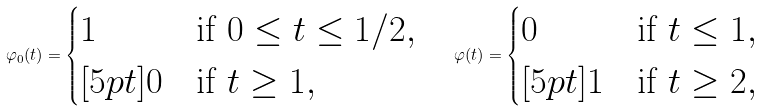<formula> <loc_0><loc_0><loc_500><loc_500>\varphi _ { 0 } ( t ) = \begin{cases} 1 & \text {if } 0 \leq t \leq 1 / 2 , \\ [ 5 p t ] 0 & \text {if } t \geq 1 , \end{cases} \quad \varphi ( t ) = \begin{cases} 0 & \text {if } t \leq 1 , \\ [ 5 p t ] 1 & \text {if } t \geq 2 , \end{cases}</formula> 